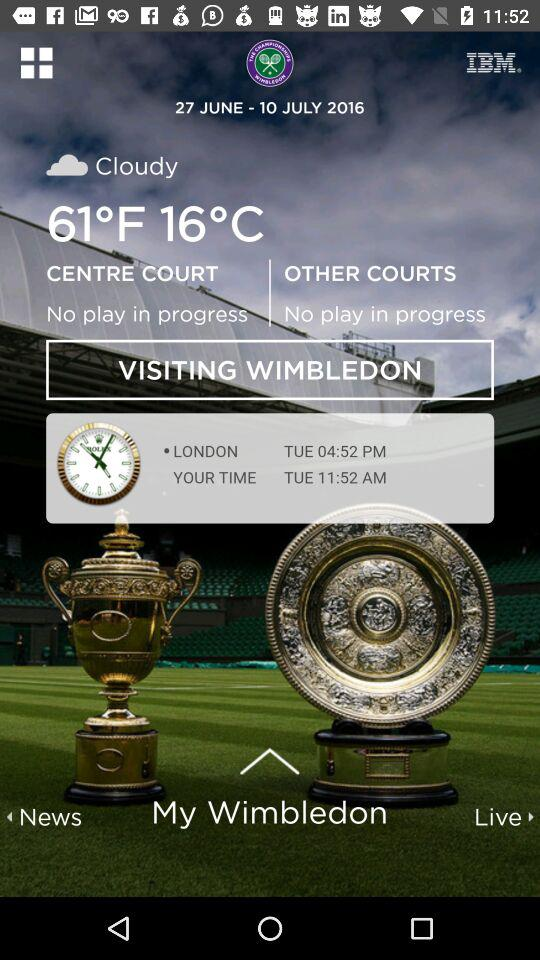What's the scheduled date range for the "Wimbledon" tournament? The scheduled date range is from June 27, 2016 to July 10, 2016. 